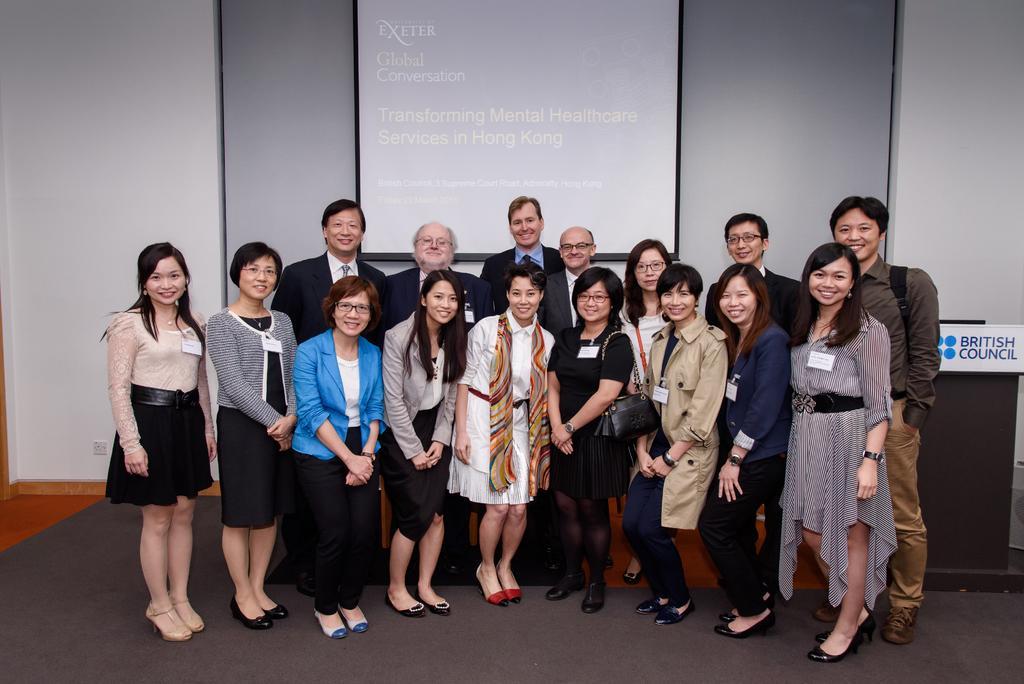Could you give a brief overview of what you see in this image? In the picture we can see a group of people are standing on the floor on a floor mat and behind them, we can see a wall with a screen and some information on it. 